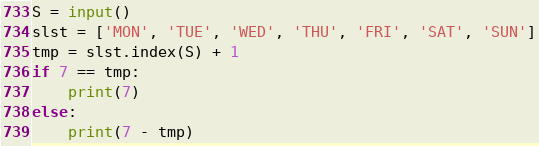Convert code to text. <code><loc_0><loc_0><loc_500><loc_500><_Python_>
S = input()
slst = ['MON', 'TUE', 'WED', 'THU', 'FRI', 'SAT', 'SUN']
tmp = slst.index(S) + 1
if 7 == tmp:
    print(7)
else:
    print(7 - tmp)</code> 